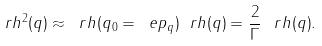<formula> <loc_0><loc_0><loc_500><loc_500>\ r h ^ { 2 } ( q ) \approx \ r h ( q _ { 0 } = \ e p _ { q } ) \ r h ( q ) = \frac { 2 } { \Gamma } \, \ r h ( q ) .</formula> 